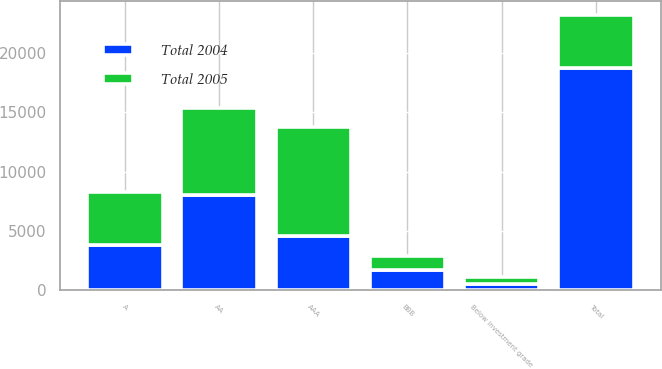Convert chart. <chart><loc_0><loc_0><loc_500><loc_500><stacked_bar_chart><ecel><fcel>AAA<fcel>AA<fcel>A<fcel>BBB<fcel>Below investment grade<fcel>Total<nl><fcel>Total 2004<fcel>4568<fcel>8057<fcel>3838<fcel>1709<fcel>523<fcel>18695<nl><fcel>Total 2005<fcel>9185<fcel>7244<fcel>4448<fcel>1193<fcel>600<fcel>4448<nl></chart> 